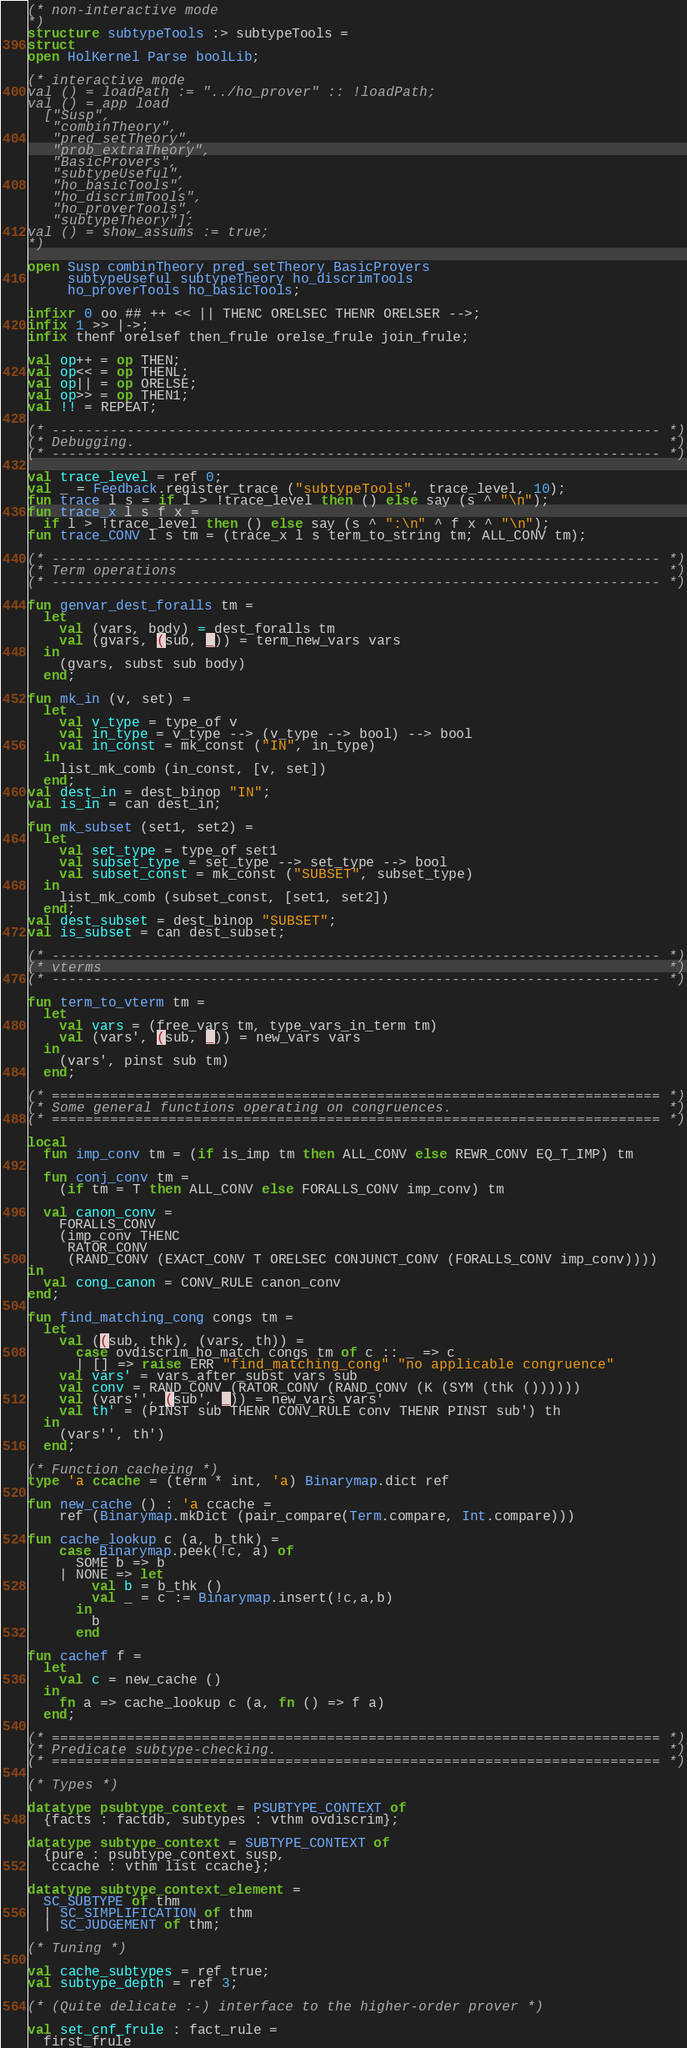<code> <loc_0><loc_0><loc_500><loc_500><_SML_>(* non-interactive mode
*)
structure subtypeTools :> subtypeTools =
struct
open HolKernel Parse boolLib;

(* interactive mode
val () = loadPath := "../ho_prover" :: !loadPath;
val () = app load
  ["Susp",
   "combinTheory",
   "pred_setTheory",
   "prob_extraTheory",
   "BasicProvers",
   "subtypeUseful",
   "ho_basicTools",
   "ho_discrimTools",
   "ho_proverTools",
   "subtypeTheory"];
val () = show_assums := true;
*)

open Susp combinTheory pred_setTheory BasicProvers
     subtypeUseful subtypeTheory ho_discrimTools
     ho_proverTools ho_basicTools;

infixr 0 oo ## ++ << || THENC ORELSEC THENR ORELSER -->;
infix 1 >> |->;
infix thenf orelsef then_frule orelse_frule join_frule;

val op++ = op THEN;
val op<< = op THENL;
val op|| = op ORELSE;
val op>> = op THEN1;
val !! = REPEAT;

(* ------------------------------------------------------------------------- *)
(* Debugging.                                                                *)
(* ------------------------------------------------------------------------- *)

val trace_level = ref 0;
val _ = Feedback.register_trace ("subtypeTools", trace_level, 10);
fun trace l s = if l > !trace_level then () else say (s ^ "\n");
fun trace_x l s f x =
  if l > !trace_level then () else say (s ^ ":\n" ^ f x ^ "\n");
fun trace_CONV l s tm = (trace_x l s term_to_string tm; ALL_CONV tm);

(* ------------------------------------------------------------------------- *)
(* Term operations                                                           *)
(* ------------------------------------------------------------------------- *)

fun genvar_dest_foralls tm =
  let
    val (vars, body) = dest_foralls tm
    val (gvars, (sub, _)) = term_new_vars vars
  in
    (gvars, subst sub body)
  end;

fun mk_in (v, set) =
  let
    val v_type = type_of v
    val in_type = v_type --> (v_type --> bool) --> bool
    val in_const = mk_const ("IN", in_type)
  in
    list_mk_comb (in_const, [v, set])
  end;
val dest_in = dest_binop "IN";
val is_in = can dest_in;

fun mk_subset (set1, set2) =
  let
    val set_type = type_of set1
    val subset_type = set_type --> set_type --> bool
    val subset_const = mk_const ("SUBSET", subset_type)
  in
    list_mk_comb (subset_const, [set1, set2])
  end;
val dest_subset = dest_binop "SUBSET";
val is_subset = can dest_subset;

(* ------------------------------------------------------------------------- *)
(* vterms                                                                    *)
(* ------------------------------------------------------------------------- *)

fun term_to_vterm tm =
  let
    val vars = (free_vars tm, type_vars_in_term tm)
    val (vars', (sub, _)) = new_vars vars
  in
    (vars', pinst sub tm)
  end;

(* ========================================================================= *)
(* Some general functions operating on congruences.                          *)
(* ========================================================================= *)

local
  fun imp_conv tm = (if is_imp tm then ALL_CONV else REWR_CONV EQ_T_IMP) tm

  fun conj_conv tm =
    (if tm = T then ALL_CONV else FORALLS_CONV imp_conv) tm

  val canon_conv =
    FORALLS_CONV
    (imp_conv THENC
     RATOR_CONV
     (RAND_CONV (EXACT_CONV T ORELSEC CONJUNCT_CONV (FORALLS_CONV imp_conv))))
in
  val cong_canon = CONV_RULE canon_conv
end;

fun find_matching_cong congs tm =
  let
    val ((sub, thk), (vars, th)) =
      case ovdiscrim_ho_match congs tm of c :: _ => c
      | [] => raise ERR "find_matching_cong" "no applicable congruence"
    val vars' = vars_after_subst vars sub
    val conv = RAND_CONV (RATOR_CONV (RAND_CONV (K (SYM (thk ())))))
    val (vars'', (sub', _)) = new_vars vars'
    val th' = (PINST sub THENR CONV_RULE conv THENR PINST sub') th
  in
    (vars'', th')
  end;

(* Function cacheing *)
type 'a ccache = (term * int, 'a) Binarymap.dict ref

fun new_cache () : 'a ccache =
    ref (Binarymap.mkDict (pair_compare(Term.compare, Int.compare)))

fun cache_lookup c (a, b_thk) =
    case Binarymap.peek(!c, a) of
      SOME b => b
    | NONE => let
        val b = b_thk ()
        val _ = c := Binarymap.insert(!c,a,b)
      in
        b
      end

fun cachef f =
  let
    val c = new_cache ()
  in
    fn a => cache_lookup c (a, fn () => f a)
  end;

(* ========================================================================= *)
(* Predicate subtype-checking.                                               *)
(* ========================================================================= *)

(* Types *)

datatype psubtype_context = PSUBTYPE_CONTEXT of
  {facts : factdb, subtypes : vthm ovdiscrim};

datatype subtype_context = SUBTYPE_CONTEXT of
  {pure : psubtype_context susp,
   ccache : vthm list ccache};

datatype subtype_context_element =
  SC_SUBTYPE of thm
  | SC_SIMPLIFICATION of thm
  | SC_JUDGEMENT of thm;

(* Tuning *)

val cache_subtypes = ref true;
val subtype_depth = ref 3;

(* (Quite delicate :-) interface to the higher-order prover *)

val set_cnf_frule : fact_rule =
  first_frule</code> 